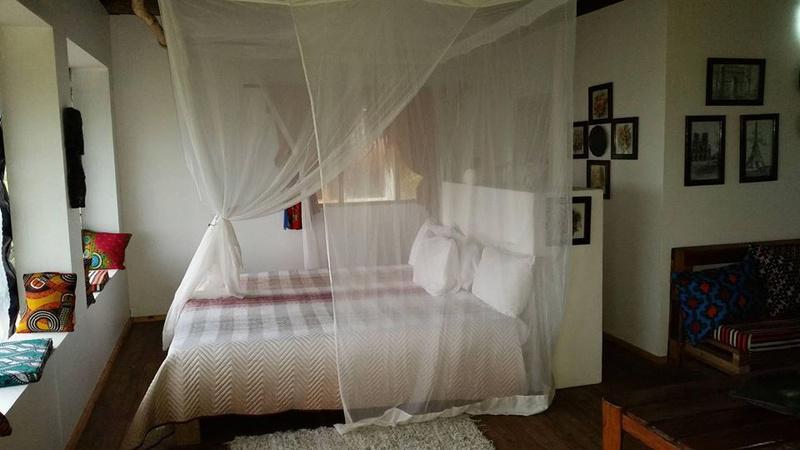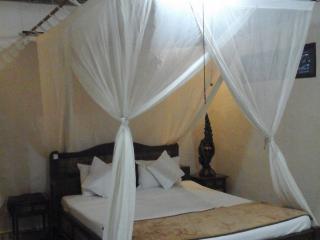The first image is the image on the left, the second image is the image on the right. Assess this claim about the two images: "At least one image shows a room with multiple beds equipped with some type of protective screens.". Correct or not? Answer yes or no. No. The first image is the image on the left, the second image is the image on the right. Assess this claim about the two images: "There are two beds in one of the images.". Correct or not? Answer yes or no. No. 